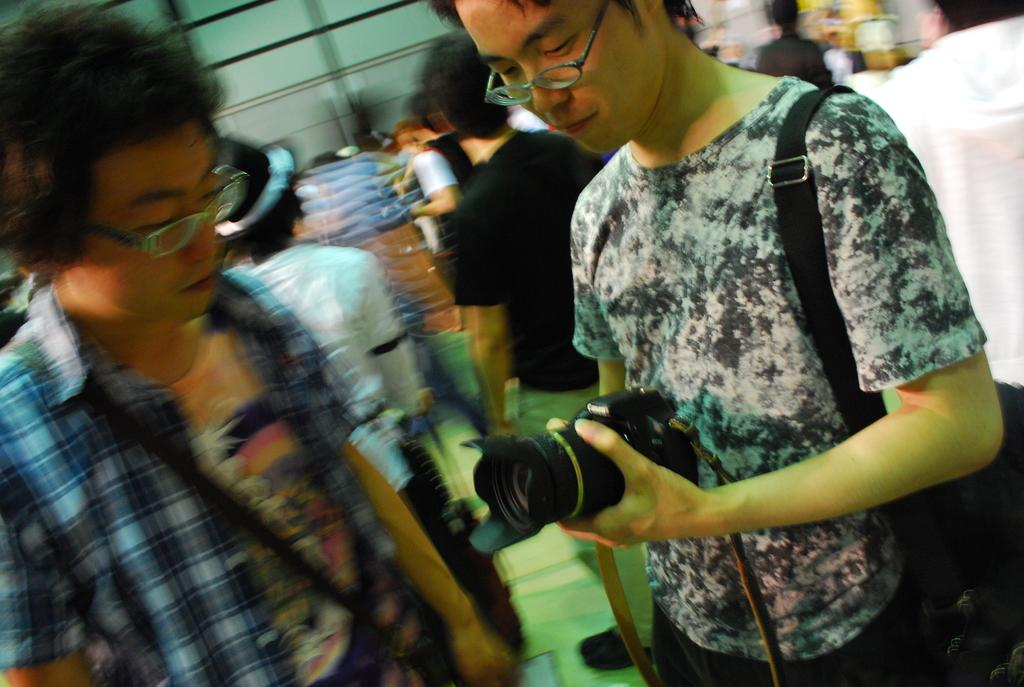What can be seen in the image involving multiple individuals? There is a group of people in the image. What object is present that is commonly used for capturing images? There is a camera in the image. What type of accessory is visible in the image? There are spectacles in the image. Can you describe any objects present in the image? There are some objects in the image, but their specific nature is not mentioned in the facts. What is visible in the background of the image? There is a wall in the background of the image. What type of ornament is hanging from the camera in the image? There is no mention of an ornament hanging from the camera in the image. What scene is being captured by the camera in the image? The facts do not provide information about the scene being captured by the camera. 